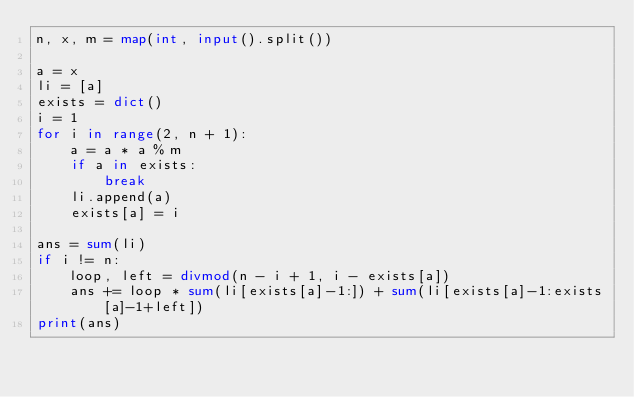Convert code to text. <code><loc_0><loc_0><loc_500><loc_500><_Python_>n, x, m = map(int, input().split())

a = x
li = [a]
exists = dict()
i = 1
for i in range(2, n + 1):
    a = a * a % m
    if a in exists:
        break
    li.append(a)
    exists[a] = i

ans = sum(li)
if i != n:
    loop, left = divmod(n - i + 1, i - exists[a])
    ans += loop * sum(li[exists[a]-1:]) + sum(li[exists[a]-1:exists[a]-1+left])
print(ans)
</code> 